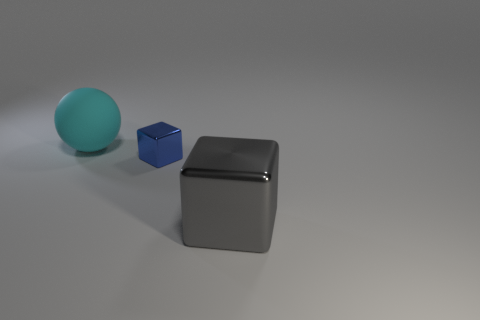How many large cyan matte objects are there?
Offer a terse response. 1. Is there anything else that has the same material as the small blue cube?
Your response must be concise. Yes. There is another gray object that is the same shape as the tiny metal thing; what is its material?
Offer a very short reply. Metal. Are there fewer gray things that are on the left side of the gray object than tiny cyan rubber things?
Ensure brevity in your answer.  No. Does the large object on the right side of the blue shiny object have the same shape as the tiny blue object?
Your answer should be compact. Yes. Is there anything else that has the same color as the big shiny block?
Ensure brevity in your answer.  No. The blue thing that is made of the same material as the large block is what size?
Make the answer very short. Small. The block that is in front of the cube left of the large object that is on the right side of the big cyan matte thing is made of what material?
Ensure brevity in your answer.  Metal. Is the number of tiny metal objects less than the number of tiny cylinders?
Your answer should be very brief. No. Do the gray block and the cyan object have the same material?
Offer a terse response. No. 